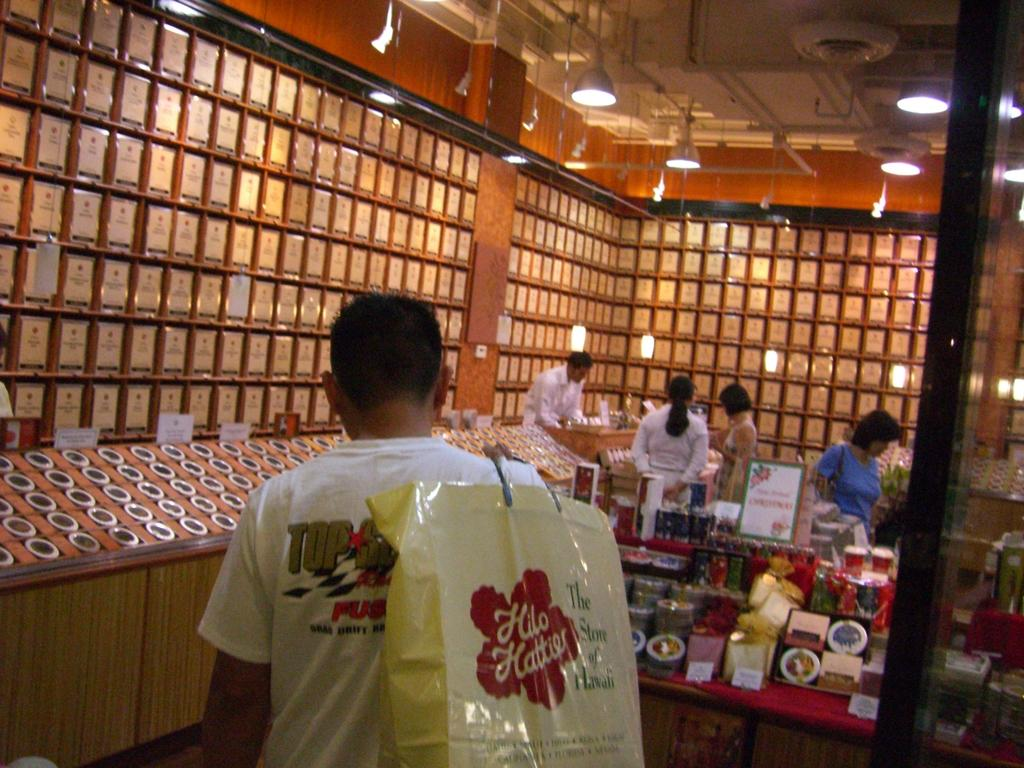How many people are in the image? There is a group of people in the image. Can you describe the man in the middle of the image? The man in the middle of the image is holding a bag. What can be seen in the background of the image? There are lights and racks with items visible in the background of the image. What type of punishment is being administered to the secretary in the image? There is no secretary or punishment present in the image. What is the location of the image, specifically in relation to downtown? The location of the image is not specified, and there is no mention of downtown in the provided facts. 